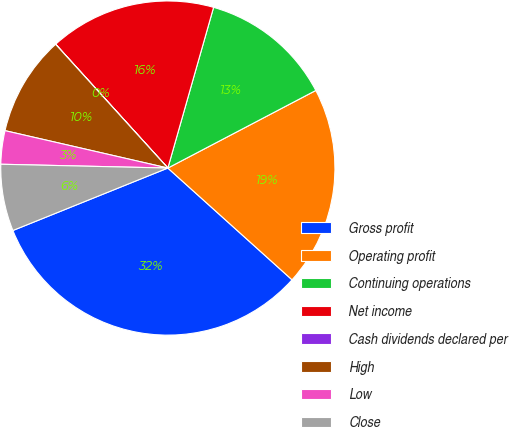Convert chart to OTSL. <chart><loc_0><loc_0><loc_500><loc_500><pie_chart><fcel>Gross profit<fcel>Operating profit<fcel>Continuing operations<fcel>Net income<fcel>Cash dividends declared per<fcel>High<fcel>Low<fcel>Close<nl><fcel>32.24%<fcel>19.35%<fcel>12.9%<fcel>16.13%<fcel>0.01%<fcel>9.68%<fcel>3.23%<fcel>6.46%<nl></chart> 